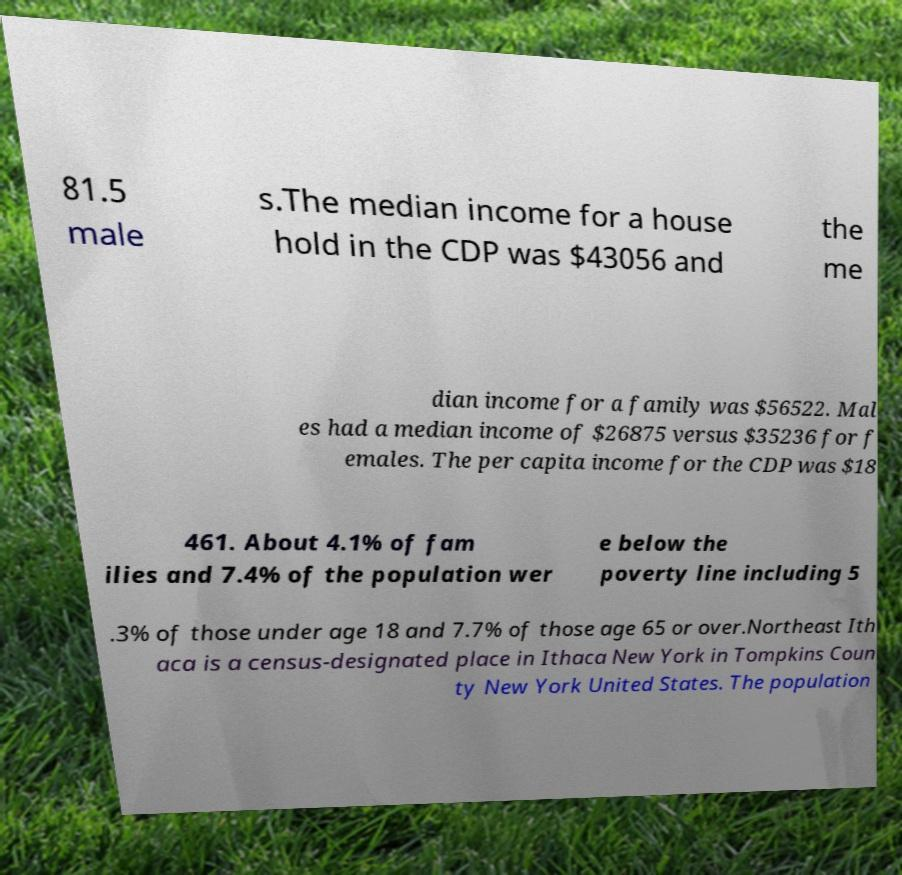I need the written content from this picture converted into text. Can you do that? 81.5 male s.The median income for a house hold in the CDP was $43056 and the me dian income for a family was $56522. Mal es had a median income of $26875 versus $35236 for f emales. The per capita income for the CDP was $18 461. About 4.1% of fam ilies and 7.4% of the population wer e below the poverty line including 5 .3% of those under age 18 and 7.7% of those age 65 or over.Northeast Ith aca is a census-designated place in Ithaca New York in Tompkins Coun ty New York United States. The population 